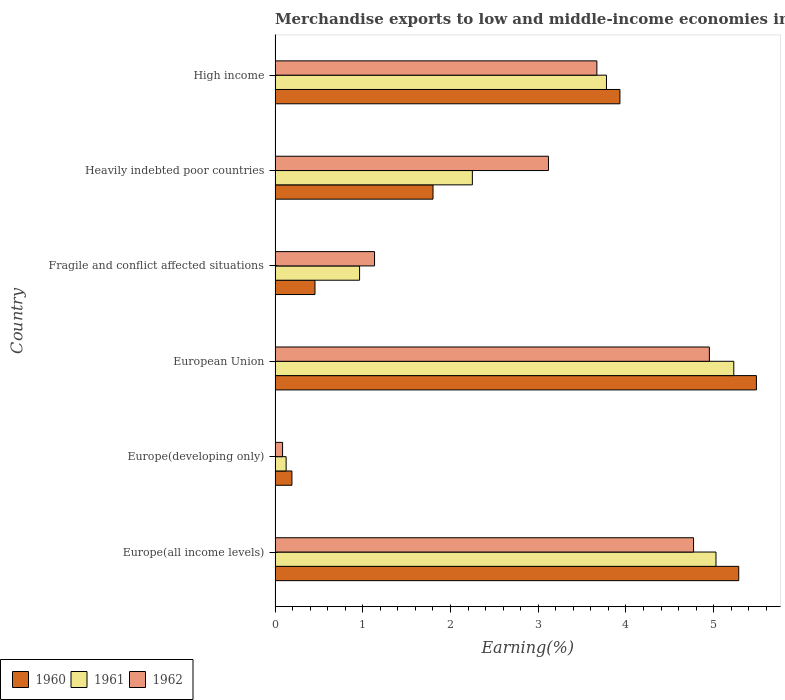How many different coloured bars are there?
Keep it short and to the point. 3. Are the number of bars per tick equal to the number of legend labels?
Your answer should be compact. Yes. What is the label of the 5th group of bars from the top?
Ensure brevity in your answer.  Europe(developing only). In how many cases, is the number of bars for a given country not equal to the number of legend labels?
Give a very brief answer. 0. What is the percentage of amount earned from merchandise exports in 1961 in Europe(all income levels)?
Your response must be concise. 5.03. Across all countries, what is the maximum percentage of amount earned from merchandise exports in 1961?
Give a very brief answer. 5.23. Across all countries, what is the minimum percentage of amount earned from merchandise exports in 1961?
Ensure brevity in your answer.  0.13. In which country was the percentage of amount earned from merchandise exports in 1961 maximum?
Your response must be concise. European Union. In which country was the percentage of amount earned from merchandise exports in 1961 minimum?
Your answer should be compact. Europe(developing only). What is the total percentage of amount earned from merchandise exports in 1961 in the graph?
Your answer should be compact. 17.37. What is the difference between the percentage of amount earned from merchandise exports in 1960 in European Union and that in High income?
Provide a short and direct response. 1.56. What is the difference between the percentage of amount earned from merchandise exports in 1961 in High income and the percentage of amount earned from merchandise exports in 1960 in Fragile and conflict affected situations?
Keep it short and to the point. 3.32. What is the average percentage of amount earned from merchandise exports in 1960 per country?
Offer a very short reply. 2.86. What is the difference between the percentage of amount earned from merchandise exports in 1961 and percentage of amount earned from merchandise exports in 1962 in Fragile and conflict affected situations?
Ensure brevity in your answer.  -0.17. In how many countries, is the percentage of amount earned from merchandise exports in 1962 greater than 2.2 %?
Give a very brief answer. 4. What is the ratio of the percentage of amount earned from merchandise exports in 1960 in Fragile and conflict affected situations to that in High income?
Your response must be concise. 0.12. Is the difference between the percentage of amount earned from merchandise exports in 1961 in Europe(developing only) and Heavily indebted poor countries greater than the difference between the percentage of amount earned from merchandise exports in 1962 in Europe(developing only) and Heavily indebted poor countries?
Your response must be concise. Yes. What is the difference between the highest and the second highest percentage of amount earned from merchandise exports in 1960?
Provide a short and direct response. 0.2. What is the difference between the highest and the lowest percentage of amount earned from merchandise exports in 1961?
Keep it short and to the point. 5.1. Is the sum of the percentage of amount earned from merchandise exports in 1961 in Europe(all income levels) and Europe(developing only) greater than the maximum percentage of amount earned from merchandise exports in 1962 across all countries?
Keep it short and to the point. Yes. What does the 1st bar from the bottom in Europe(developing only) represents?
Your response must be concise. 1960. How many countries are there in the graph?
Make the answer very short. 6. What is the difference between two consecutive major ticks on the X-axis?
Keep it short and to the point. 1. Are the values on the major ticks of X-axis written in scientific E-notation?
Ensure brevity in your answer.  No. Does the graph contain any zero values?
Provide a short and direct response. No. Does the graph contain grids?
Ensure brevity in your answer.  No. Where does the legend appear in the graph?
Make the answer very short. Bottom left. How many legend labels are there?
Make the answer very short. 3. What is the title of the graph?
Provide a succinct answer. Merchandise exports to low and middle-income economies in Saharan Africa. Does "2005" appear as one of the legend labels in the graph?
Offer a very short reply. No. What is the label or title of the X-axis?
Offer a terse response. Earning(%). What is the label or title of the Y-axis?
Keep it short and to the point. Country. What is the Earning(%) of 1960 in Europe(all income levels)?
Provide a succinct answer. 5.29. What is the Earning(%) in 1961 in Europe(all income levels)?
Provide a succinct answer. 5.03. What is the Earning(%) in 1962 in Europe(all income levels)?
Your response must be concise. 4.77. What is the Earning(%) of 1960 in Europe(developing only)?
Offer a very short reply. 0.19. What is the Earning(%) of 1961 in Europe(developing only)?
Offer a terse response. 0.13. What is the Earning(%) of 1962 in Europe(developing only)?
Make the answer very short. 0.09. What is the Earning(%) of 1960 in European Union?
Your answer should be compact. 5.49. What is the Earning(%) of 1961 in European Union?
Provide a short and direct response. 5.23. What is the Earning(%) of 1962 in European Union?
Offer a very short reply. 4.95. What is the Earning(%) in 1960 in Fragile and conflict affected situations?
Keep it short and to the point. 0.45. What is the Earning(%) in 1961 in Fragile and conflict affected situations?
Offer a very short reply. 0.96. What is the Earning(%) of 1962 in Fragile and conflict affected situations?
Offer a very short reply. 1.13. What is the Earning(%) of 1960 in Heavily indebted poor countries?
Your response must be concise. 1.8. What is the Earning(%) of 1961 in Heavily indebted poor countries?
Provide a succinct answer. 2.25. What is the Earning(%) in 1962 in Heavily indebted poor countries?
Give a very brief answer. 3.12. What is the Earning(%) of 1960 in High income?
Your answer should be compact. 3.93. What is the Earning(%) of 1961 in High income?
Keep it short and to the point. 3.78. What is the Earning(%) in 1962 in High income?
Provide a short and direct response. 3.67. Across all countries, what is the maximum Earning(%) in 1960?
Your answer should be compact. 5.49. Across all countries, what is the maximum Earning(%) of 1961?
Your response must be concise. 5.23. Across all countries, what is the maximum Earning(%) of 1962?
Provide a succinct answer. 4.95. Across all countries, what is the minimum Earning(%) of 1960?
Ensure brevity in your answer.  0.19. Across all countries, what is the minimum Earning(%) in 1961?
Provide a short and direct response. 0.13. Across all countries, what is the minimum Earning(%) in 1962?
Provide a succinct answer. 0.09. What is the total Earning(%) in 1960 in the graph?
Offer a terse response. 17.15. What is the total Earning(%) of 1961 in the graph?
Provide a succinct answer. 17.37. What is the total Earning(%) in 1962 in the graph?
Your answer should be very brief. 17.72. What is the difference between the Earning(%) in 1960 in Europe(all income levels) and that in Europe(developing only)?
Keep it short and to the point. 5.09. What is the difference between the Earning(%) in 1961 in Europe(all income levels) and that in Europe(developing only)?
Your answer should be compact. 4.9. What is the difference between the Earning(%) in 1962 in Europe(all income levels) and that in Europe(developing only)?
Keep it short and to the point. 4.68. What is the difference between the Earning(%) in 1960 in Europe(all income levels) and that in European Union?
Offer a terse response. -0.2. What is the difference between the Earning(%) of 1961 in Europe(all income levels) and that in European Union?
Provide a short and direct response. -0.2. What is the difference between the Earning(%) in 1962 in Europe(all income levels) and that in European Union?
Your response must be concise. -0.18. What is the difference between the Earning(%) of 1960 in Europe(all income levels) and that in Fragile and conflict affected situations?
Ensure brevity in your answer.  4.83. What is the difference between the Earning(%) of 1961 in Europe(all income levels) and that in Fragile and conflict affected situations?
Provide a succinct answer. 4.06. What is the difference between the Earning(%) in 1962 in Europe(all income levels) and that in Fragile and conflict affected situations?
Keep it short and to the point. 3.64. What is the difference between the Earning(%) of 1960 in Europe(all income levels) and that in Heavily indebted poor countries?
Offer a very short reply. 3.48. What is the difference between the Earning(%) of 1961 in Europe(all income levels) and that in Heavily indebted poor countries?
Your answer should be very brief. 2.78. What is the difference between the Earning(%) of 1962 in Europe(all income levels) and that in Heavily indebted poor countries?
Give a very brief answer. 1.65. What is the difference between the Earning(%) in 1960 in Europe(all income levels) and that in High income?
Your answer should be compact. 1.35. What is the difference between the Earning(%) of 1961 in Europe(all income levels) and that in High income?
Make the answer very short. 1.25. What is the difference between the Earning(%) in 1962 in Europe(all income levels) and that in High income?
Provide a short and direct response. 1.1. What is the difference between the Earning(%) of 1960 in Europe(developing only) and that in European Union?
Your response must be concise. -5.29. What is the difference between the Earning(%) of 1961 in Europe(developing only) and that in European Union?
Give a very brief answer. -5.1. What is the difference between the Earning(%) in 1962 in Europe(developing only) and that in European Union?
Make the answer very short. -4.87. What is the difference between the Earning(%) of 1960 in Europe(developing only) and that in Fragile and conflict affected situations?
Your answer should be very brief. -0.26. What is the difference between the Earning(%) of 1961 in Europe(developing only) and that in Fragile and conflict affected situations?
Give a very brief answer. -0.84. What is the difference between the Earning(%) in 1962 in Europe(developing only) and that in Fragile and conflict affected situations?
Keep it short and to the point. -1.05. What is the difference between the Earning(%) in 1960 in Europe(developing only) and that in Heavily indebted poor countries?
Your answer should be very brief. -1.61. What is the difference between the Earning(%) of 1961 in Europe(developing only) and that in Heavily indebted poor countries?
Your answer should be compact. -2.12. What is the difference between the Earning(%) in 1962 in Europe(developing only) and that in Heavily indebted poor countries?
Keep it short and to the point. -3.03. What is the difference between the Earning(%) of 1960 in Europe(developing only) and that in High income?
Your response must be concise. -3.74. What is the difference between the Earning(%) in 1961 in Europe(developing only) and that in High income?
Ensure brevity in your answer.  -3.65. What is the difference between the Earning(%) in 1962 in Europe(developing only) and that in High income?
Your answer should be very brief. -3.58. What is the difference between the Earning(%) in 1960 in European Union and that in Fragile and conflict affected situations?
Your response must be concise. 5.03. What is the difference between the Earning(%) of 1961 in European Union and that in Fragile and conflict affected situations?
Offer a very short reply. 4.27. What is the difference between the Earning(%) of 1962 in European Union and that in Fragile and conflict affected situations?
Your answer should be very brief. 3.82. What is the difference between the Earning(%) in 1960 in European Union and that in Heavily indebted poor countries?
Your answer should be very brief. 3.69. What is the difference between the Earning(%) of 1961 in European Union and that in Heavily indebted poor countries?
Ensure brevity in your answer.  2.98. What is the difference between the Earning(%) in 1962 in European Union and that in Heavily indebted poor countries?
Offer a terse response. 1.83. What is the difference between the Earning(%) in 1960 in European Union and that in High income?
Your answer should be very brief. 1.56. What is the difference between the Earning(%) of 1961 in European Union and that in High income?
Provide a succinct answer. 1.45. What is the difference between the Earning(%) in 1962 in European Union and that in High income?
Provide a succinct answer. 1.28. What is the difference between the Earning(%) in 1960 in Fragile and conflict affected situations and that in Heavily indebted poor countries?
Keep it short and to the point. -1.35. What is the difference between the Earning(%) in 1961 in Fragile and conflict affected situations and that in Heavily indebted poor countries?
Make the answer very short. -1.29. What is the difference between the Earning(%) of 1962 in Fragile and conflict affected situations and that in Heavily indebted poor countries?
Give a very brief answer. -1.98. What is the difference between the Earning(%) of 1960 in Fragile and conflict affected situations and that in High income?
Your answer should be very brief. -3.48. What is the difference between the Earning(%) of 1961 in Fragile and conflict affected situations and that in High income?
Your answer should be compact. -2.81. What is the difference between the Earning(%) of 1962 in Fragile and conflict affected situations and that in High income?
Keep it short and to the point. -2.53. What is the difference between the Earning(%) of 1960 in Heavily indebted poor countries and that in High income?
Offer a terse response. -2.13. What is the difference between the Earning(%) of 1961 in Heavily indebted poor countries and that in High income?
Keep it short and to the point. -1.53. What is the difference between the Earning(%) in 1962 in Heavily indebted poor countries and that in High income?
Your answer should be very brief. -0.55. What is the difference between the Earning(%) of 1960 in Europe(all income levels) and the Earning(%) of 1961 in Europe(developing only)?
Offer a very short reply. 5.16. What is the difference between the Earning(%) in 1960 in Europe(all income levels) and the Earning(%) in 1962 in Europe(developing only)?
Your answer should be compact. 5.2. What is the difference between the Earning(%) of 1961 in Europe(all income levels) and the Earning(%) of 1962 in Europe(developing only)?
Offer a terse response. 4.94. What is the difference between the Earning(%) of 1960 in Europe(all income levels) and the Earning(%) of 1961 in European Union?
Your response must be concise. 0.06. What is the difference between the Earning(%) in 1960 in Europe(all income levels) and the Earning(%) in 1962 in European Union?
Provide a short and direct response. 0.33. What is the difference between the Earning(%) of 1961 in Europe(all income levels) and the Earning(%) of 1962 in European Union?
Your answer should be very brief. 0.08. What is the difference between the Earning(%) in 1960 in Europe(all income levels) and the Earning(%) in 1961 in Fragile and conflict affected situations?
Give a very brief answer. 4.32. What is the difference between the Earning(%) in 1960 in Europe(all income levels) and the Earning(%) in 1962 in Fragile and conflict affected situations?
Ensure brevity in your answer.  4.15. What is the difference between the Earning(%) in 1961 in Europe(all income levels) and the Earning(%) in 1962 in Fragile and conflict affected situations?
Offer a terse response. 3.89. What is the difference between the Earning(%) in 1960 in Europe(all income levels) and the Earning(%) in 1961 in Heavily indebted poor countries?
Ensure brevity in your answer.  3.04. What is the difference between the Earning(%) in 1960 in Europe(all income levels) and the Earning(%) in 1962 in Heavily indebted poor countries?
Offer a very short reply. 2.17. What is the difference between the Earning(%) in 1961 in Europe(all income levels) and the Earning(%) in 1962 in Heavily indebted poor countries?
Keep it short and to the point. 1.91. What is the difference between the Earning(%) in 1960 in Europe(all income levels) and the Earning(%) in 1961 in High income?
Offer a very short reply. 1.51. What is the difference between the Earning(%) in 1960 in Europe(all income levels) and the Earning(%) in 1962 in High income?
Give a very brief answer. 1.62. What is the difference between the Earning(%) of 1961 in Europe(all income levels) and the Earning(%) of 1962 in High income?
Your answer should be compact. 1.36. What is the difference between the Earning(%) of 1960 in Europe(developing only) and the Earning(%) of 1961 in European Union?
Make the answer very short. -5.04. What is the difference between the Earning(%) of 1960 in Europe(developing only) and the Earning(%) of 1962 in European Union?
Keep it short and to the point. -4.76. What is the difference between the Earning(%) in 1961 in Europe(developing only) and the Earning(%) in 1962 in European Union?
Give a very brief answer. -4.82. What is the difference between the Earning(%) of 1960 in Europe(developing only) and the Earning(%) of 1961 in Fragile and conflict affected situations?
Offer a terse response. -0.77. What is the difference between the Earning(%) in 1960 in Europe(developing only) and the Earning(%) in 1962 in Fragile and conflict affected situations?
Offer a very short reply. -0.94. What is the difference between the Earning(%) of 1961 in Europe(developing only) and the Earning(%) of 1962 in Fragile and conflict affected situations?
Give a very brief answer. -1.01. What is the difference between the Earning(%) of 1960 in Europe(developing only) and the Earning(%) of 1961 in Heavily indebted poor countries?
Your response must be concise. -2.06. What is the difference between the Earning(%) in 1960 in Europe(developing only) and the Earning(%) in 1962 in Heavily indebted poor countries?
Keep it short and to the point. -2.92. What is the difference between the Earning(%) in 1961 in Europe(developing only) and the Earning(%) in 1962 in Heavily indebted poor countries?
Make the answer very short. -2.99. What is the difference between the Earning(%) in 1960 in Europe(developing only) and the Earning(%) in 1961 in High income?
Offer a very short reply. -3.59. What is the difference between the Earning(%) in 1960 in Europe(developing only) and the Earning(%) in 1962 in High income?
Keep it short and to the point. -3.48. What is the difference between the Earning(%) of 1961 in Europe(developing only) and the Earning(%) of 1962 in High income?
Keep it short and to the point. -3.54. What is the difference between the Earning(%) of 1960 in European Union and the Earning(%) of 1961 in Fragile and conflict affected situations?
Your answer should be compact. 4.52. What is the difference between the Earning(%) in 1960 in European Union and the Earning(%) in 1962 in Fragile and conflict affected situations?
Provide a short and direct response. 4.35. What is the difference between the Earning(%) in 1961 in European Union and the Earning(%) in 1962 in Fragile and conflict affected situations?
Provide a short and direct response. 4.1. What is the difference between the Earning(%) of 1960 in European Union and the Earning(%) of 1961 in Heavily indebted poor countries?
Give a very brief answer. 3.24. What is the difference between the Earning(%) in 1960 in European Union and the Earning(%) in 1962 in Heavily indebted poor countries?
Ensure brevity in your answer.  2.37. What is the difference between the Earning(%) in 1961 in European Union and the Earning(%) in 1962 in Heavily indebted poor countries?
Give a very brief answer. 2.11. What is the difference between the Earning(%) in 1960 in European Union and the Earning(%) in 1961 in High income?
Ensure brevity in your answer.  1.71. What is the difference between the Earning(%) of 1960 in European Union and the Earning(%) of 1962 in High income?
Provide a succinct answer. 1.82. What is the difference between the Earning(%) in 1961 in European Union and the Earning(%) in 1962 in High income?
Offer a very short reply. 1.56. What is the difference between the Earning(%) of 1960 in Fragile and conflict affected situations and the Earning(%) of 1961 in Heavily indebted poor countries?
Provide a succinct answer. -1.79. What is the difference between the Earning(%) in 1960 in Fragile and conflict affected situations and the Earning(%) in 1962 in Heavily indebted poor countries?
Make the answer very short. -2.66. What is the difference between the Earning(%) of 1961 in Fragile and conflict affected situations and the Earning(%) of 1962 in Heavily indebted poor countries?
Ensure brevity in your answer.  -2.15. What is the difference between the Earning(%) in 1960 in Fragile and conflict affected situations and the Earning(%) in 1961 in High income?
Ensure brevity in your answer.  -3.32. What is the difference between the Earning(%) in 1960 in Fragile and conflict affected situations and the Earning(%) in 1962 in High income?
Provide a short and direct response. -3.21. What is the difference between the Earning(%) in 1961 in Fragile and conflict affected situations and the Earning(%) in 1962 in High income?
Your response must be concise. -2.7. What is the difference between the Earning(%) in 1960 in Heavily indebted poor countries and the Earning(%) in 1961 in High income?
Give a very brief answer. -1.98. What is the difference between the Earning(%) of 1960 in Heavily indebted poor countries and the Earning(%) of 1962 in High income?
Keep it short and to the point. -1.87. What is the difference between the Earning(%) of 1961 in Heavily indebted poor countries and the Earning(%) of 1962 in High income?
Provide a short and direct response. -1.42. What is the average Earning(%) in 1960 per country?
Your answer should be compact. 2.86. What is the average Earning(%) in 1961 per country?
Your answer should be very brief. 2.9. What is the average Earning(%) in 1962 per country?
Provide a succinct answer. 2.95. What is the difference between the Earning(%) in 1960 and Earning(%) in 1961 in Europe(all income levels)?
Keep it short and to the point. 0.26. What is the difference between the Earning(%) of 1960 and Earning(%) of 1962 in Europe(all income levels)?
Provide a short and direct response. 0.52. What is the difference between the Earning(%) of 1961 and Earning(%) of 1962 in Europe(all income levels)?
Your response must be concise. 0.26. What is the difference between the Earning(%) in 1960 and Earning(%) in 1961 in Europe(developing only)?
Give a very brief answer. 0.07. What is the difference between the Earning(%) in 1960 and Earning(%) in 1962 in Europe(developing only)?
Ensure brevity in your answer.  0.11. What is the difference between the Earning(%) of 1961 and Earning(%) of 1962 in Europe(developing only)?
Make the answer very short. 0.04. What is the difference between the Earning(%) in 1960 and Earning(%) in 1961 in European Union?
Offer a very short reply. 0.26. What is the difference between the Earning(%) in 1960 and Earning(%) in 1962 in European Union?
Offer a terse response. 0.54. What is the difference between the Earning(%) of 1961 and Earning(%) of 1962 in European Union?
Ensure brevity in your answer.  0.28. What is the difference between the Earning(%) of 1960 and Earning(%) of 1961 in Fragile and conflict affected situations?
Your response must be concise. -0.51. What is the difference between the Earning(%) in 1960 and Earning(%) in 1962 in Fragile and conflict affected situations?
Provide a short and direct response. -0.68. What is the difference between the Earning(%) of 1961 and Earning(%) of 1962 in Fragile and conflict affected situations?
Your answer should be compact. -0.17. What is the difference between the Earning(%) in 1960 and Earning(%) in 1961 in Heavily indebted poor countries?
Provide a succinct answer. -0.45. What is the difference between the Earning(%) of 1960 and Earning(%) of 1962 in Heavily indebted poor countries?
Offer a very short reply. -1.32. What is the difference between the Earning(%) of 1961 and Earning(%) of 1962 in Heavily indebted poor countries?
Offer a terse response. -0.87. What is the difference between the Earning(%) of 1960 and Earning(%) of 1961 in High income?
Provide a short and direct response. 0.15. What is the difference between the Earning(%) of 1960 and Earning(%) of 1962 in High income?
Offer a terse response. 0.26. What is the difference between the Earning(%) of 1961 and Earning(%) of 1962 in High income?
Your response must be concise. 0.11. What is the ratio of the Earning(%) of 1960 in Europe(all income levels) to that in Europe(developing only)?
Give a very brief answer. 27.54. What is the ratio of the Earning(%) of 1961 in Europe(all income levels) to that in Europe(developing only)?
Ensure brevity in your answer.  39.9. What is the ratio of the Earning(%) of 1962 in Europe(all income levels) to that in Europe(developing only)?
Offer a terse response. 55.85. What is the ratio of the Earning(%) in 1960 in Europe(all income levels) to that in European Union?
Offer a very short reply. 0.96. What is the ratio of the Earning(%) of 1961 in Europe(all income levels) to that in European Union?
Offer a very short reply. 0.96. What is the ratio of the Earning(%) in 1962 in Europe(all income levels) to that in European Union?
Your answer should be very brief. 0.96. What is the ratio of the Earning(%) in 1960 in Europe(all income levels) to that in Fragile and conflict affected situations?
Give a very brief answer. 11.62. What is the ratio of the Earning(%) in 1961 in Europe(all income levels) to that in Fragile and conflict affected situations?
Provide a short and direct response. 5.22. What is the ratio of the Earning(%) of 1962 in Europe(all income levels) to that in Fragile and conflict affected situations?
Offer a terse response. 4.21. What is the ratio of the Earning(%) of 1960 in Europe(all income levels) to that in Heavily indebted poor countries?
Give a very brief answer. 2.94. What is the ratio of the Earning(%) in 1961 in Europe(all income levels) to that in Heavily indebted poor countries?
Ensure brevity in your answer.  2.23. What is the ratio of the Earning(%) in 1962 in Europe(all income levels) to that in Heavily indebted poor countries?
Provide a short and direct response. 1.53. What is the ratio of the Earning(%) of 1960 in Europe(all income levels) to that in High income?
Provide a short and direct response. 1.34. What is the ratio of the Earning(%) of 1961 in Europe(all income levels) to that in High income?
Provide a short and direct response. 1.33. What is the ratio of the Earning(%) of 1962 in Europe(all income levels) to that in High income?
Your answer should be very brief. 1.3. What is the ratio of the Earning(%) of 1960 in Europe(developing only) to that in European Union?
Offer a terse response. 0.04. What is the ratio of the Earning(%) of 1961 in Europe(developing only) to that in European Union?
Provide a short and direct response. 0.02. What is the ratio of the Earning(%) in 1962 in Europe(developing only) to that in European Union?
Provide a short and direct response. 0.02. What is the ratio of the Earning(%) of 1960 in Europe(developing only) to that in Fragile and conflict affected situations?
Your answer should be very brief. 0.42. What is the ratio of the Earning(%) of 1961 in Europe(developing only) to that in Fragile and conflict affected situations?
Your response must be concise. 0.13. What is the ratio of the Earning(%) in 1962 in Europe(developing only) to that in Fragile and conflict affected situations?
Your answer should be very brief. 0.08. What is the ratio of the Earning(%) in 1960 in Europe(developing only) to that in Heavily indebted poor countries?
Your answer should be very brief. 0.11. What is the ratio of the Earning(%) of 1961 in Europe(developing only) to that in Heavily indebted poor countries?
Make the answer very short. 0.06. What is the ratio of the Earning(%) in 1962 in Europe(developing only) to that in Heavily indebted poor countries?
Give a very brief answer. 0.03. What is the ratio of the Earning(%) of 1960 in Europe(developing only) to that in High income?
Offer a very short reply. 0.05. What is the ratio of the Earning(%) of 1961 in Europe(developing only) to that in High income?
Provide a succinct answer. 0.03. What is the ratio of the Earning(%) in 1962 in Europe(developing only) to that in High income?
Offer a terse response. 0.02. What is the ratio of the Earning(%) of 1960 in European Union to that in Fragile and conflict affected situations?
Make the answer very short. 12.06. What is the ratio of the Earning(%) of 1961 in European Union to that in Fragile and conflict affected situations?
Your answer should be very brief. 5.43. What is the ratio of the Earning(%) in 1962 in European Union to that in Fragile and conflict affected situations?
Your answer should be compact. 4.37. What is the ratio of the Earning(%) in 1960 in European Union to that in Heavily indebted poor countries?
Your answer should be compact. 3.05. What is the ratio of the Earning(%) of 1961 in European Union to that in Heavily indebted poor countries?
Offer a very short reply. 2.33. What is the ratio of the Earning(%) of 1962 in European Union to that in Heavily indebted poor countries?
Give a very brief answer. 1.59. What is the ratio of the Earning(%) in 1960 in European Union to that in High income?
Ensure brevity in your answer.  1.4. What is the ratio of the Earning(%) in 1961 in European Union to that in High income?
Provide a succinct answer. 1.38. What is the ratio of the Earning(%) of 1962 in European Union to that in High income?
Offer a terse response. 1.35. What is the ratio of the Earning(%) of 1960 in Fragile and conflict affected situations to that in Heavily indebted poor countries?
Offer a very short reply. 0.25. What is the ratio of the Earning(%) in 1961 in Fragile and conflict affected situations to that in Heavily indebted poor countries?
Offer a terse response. 0.43. What is the ratio of the Earning(%) of 1962 in Fragile and conflict affected situations to that in Heavily indebted poor countries?
Your response must be concise. 0.36. What is the ratio of the Earning(%) of 1960 in Fragile and conflict affected situations to that in High income?
Provide a succinct answer. 0.12. What is the ratio of the Earning(%) of 1961 in Fragile and conflict affected situations to that in High income?
Provide a succinct answer. 0.26. What is the ratio of the Earning(%) in 1962 in Fragile and conflict affected situations to that in High income?
Provide a short and direct response. 0.31. What is the ratio of the Earning(%) of 1960 in Heavily indebted poor countries to that in High income?
Offer a terse response. 0.46. What is the ratio of the Earning(%) in 1961 in Heavily indebted poor countries to that in High income?
Your answer should be compact. 0.6. What is the ratio of the Earning(%) in 1962 in Heavily indebted poor countries to that in High income?
Provide a succinct answer. 0.85. What is the difference between the highest and the second highest Earning(%) in 1960?
Your answer should be compact. 0.2. What is the difference between the highest and the second highest Earning(%) of 1961?
Your response must be concise. 0.2. What is the difference between the highest and the second highest Earning(%) in 1962?
Offer a very short reply. 0.18. What is the difference between the highest and the lowest Earning(%) in 1960?
Make the answer very short. 5.29. What is the difference between the highest and the lowest Earning(%) in 1961?
Offer a terse response. 5.1. What is the difference between the highest and the lowest Earning(%) of 1962?
Ensure brevity in your answer.  4.87. 